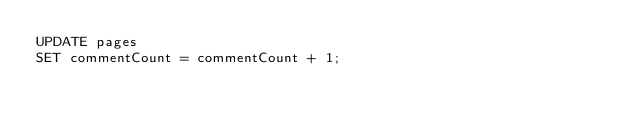<code> <loc_0><loc_0><loc_500><loc_500><_SQL_>UPDATE pages
SET commentCount = commentCount + 1;
</code> 